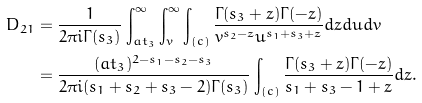Convert formula to latex. <formula><loc_0><loc_0><loc_500><loc_500>D _ { 2 1 } & = \frac { 1 } { 2 \pi i \Gamma ( s _ { 3 } ) } \int _ { a t _ { 3 } } ^ { \infty } \int _ { v } ^ { \infty } \int _ { ( c ) } \frac { \Gamma ( s _ { 3 } + z ) \Gamma ( - z ) } { v ^ { s _ { 2 } - z } u ^ { s _ { 1 } + s _ { 3 } + z } } d z d u d v \\ & = \frac { ( a t _ { 3 } ) ^ { 2 - s _ { 1 } - s _ { 2 } - s _ { 3 } } } { 2 \pi i ( s _ { 1 } + s _ { 2 } + s _ { 3 } - 2 ) \Gamma ( s _ { 3 } ) } \int _ { ( c ) } \frac { \Gamma ( s _ { 3 } + z ) \Gamma ( - z ) } { s _ { 1 } + s _ { 3 } - 1 + z } d z .</formula> 